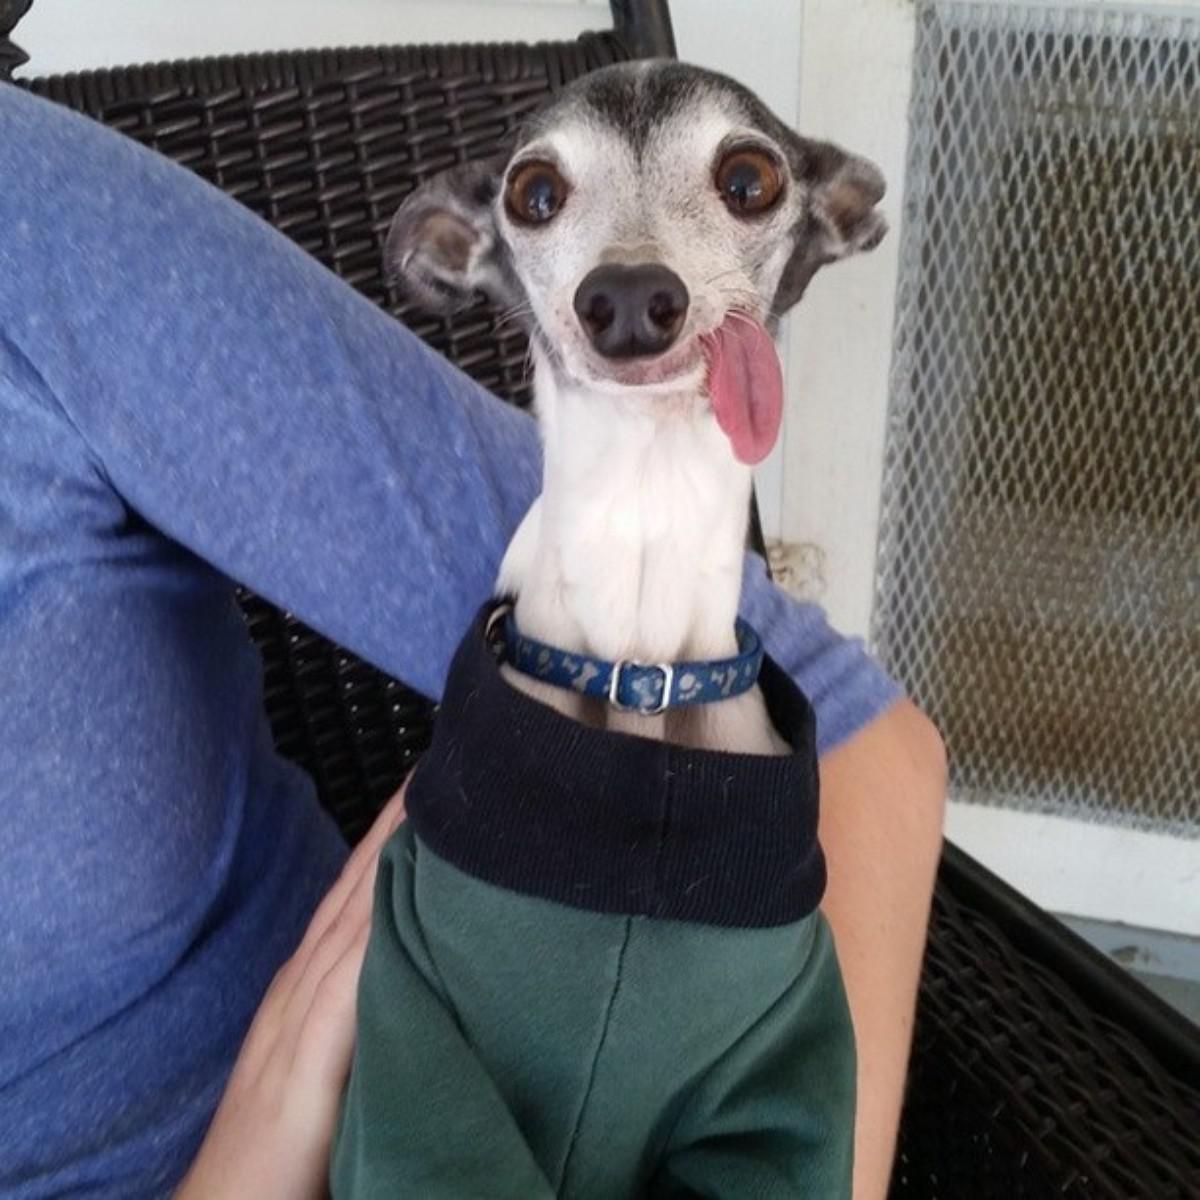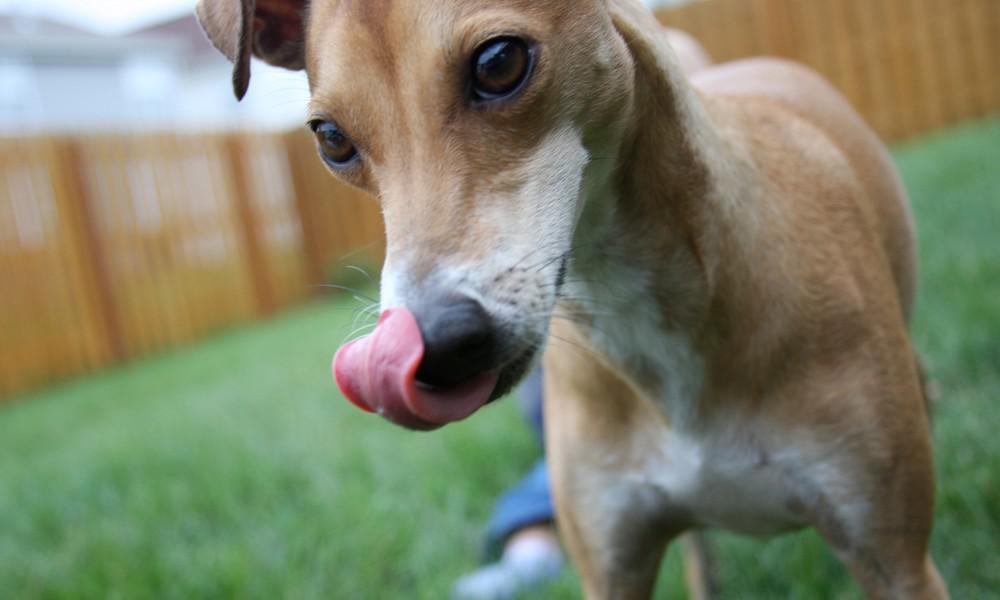The first image is the image on the left, the second image is the image on the right. Considering the images on both sides, is "In one image, a dog is being cradled in a person's arm." valid? Answer yes or no. Yes. The first image is the image on the left, the second image is the image on the right. For the images displayed, is the sentence "The right image contains no more than one dog." factually correct? Answer yes or no. Yes. The first image is the image on the left, the second image is the image on the right. Analyze the images presented: Is the assertion "Several hounds are resting together on something manmade, neutral-colored and plush." valid? Answer yes or no. No. The first image is the image on the left, the second image is the image on the right. Examine the images to the left and right. Is the description "There are more dogs in the right image than in the left." accurate? Answer yes or no. No. 